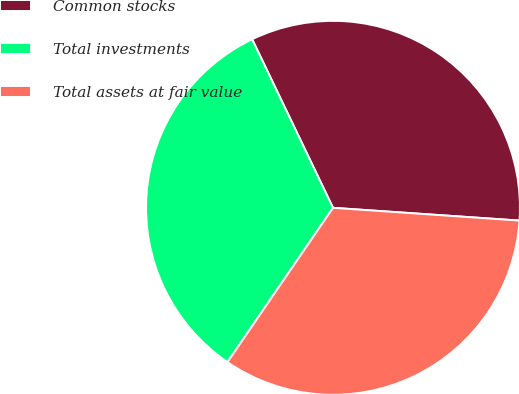Convert chart to OTSL. <chart><loc_0><loc_0><loc_500><loc_500><pie_chart><fcel>Common stocks<fcel>Total investments<fcel>Total assets at fair value<nl><fcel>33.21%<fcel>33.33%<fcel>33.46%<nl></chart> 